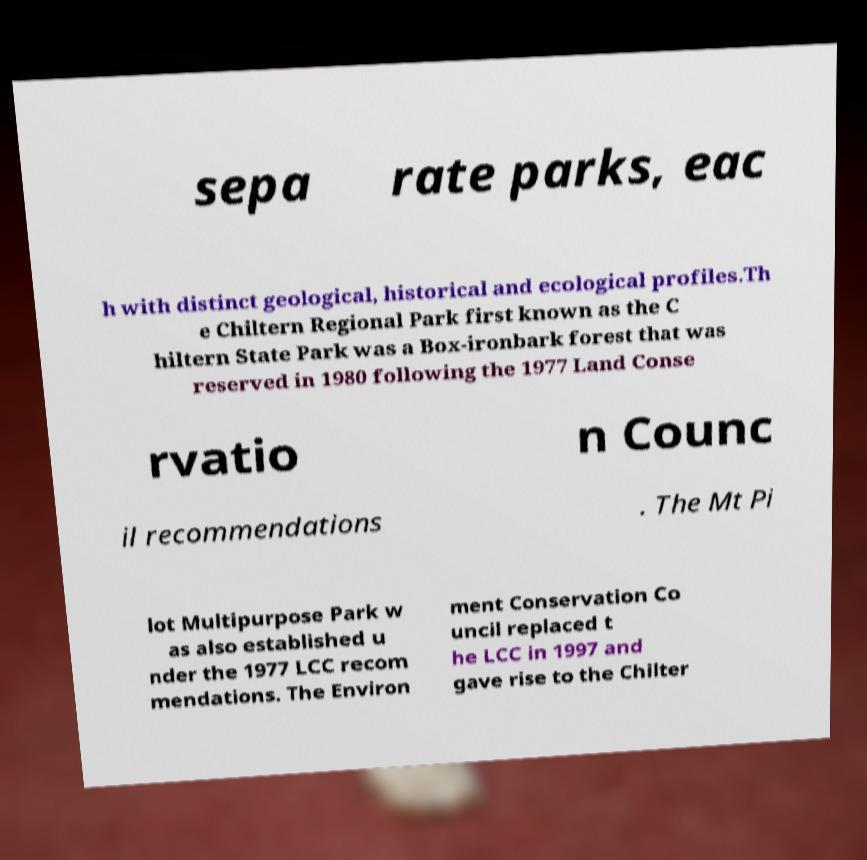Please identify and transcribe the text found in this image. sepa rate parks, eac h with distinct geological, historical and ecological profiles.Th e Chiltern Regional Park first known as the C hiltern State Park was a Box-ironbark forest that was reserved in 1980 following the 1977 Land Conse rvatio n Counc il recommendations . The Mt Pi lot Multipurpose Park w as also established u nder the 1977 LCC recom mendations. The Environ ment Conservation Co uncil replaced t he LCC in 1997 and gave rise to the Chilter 